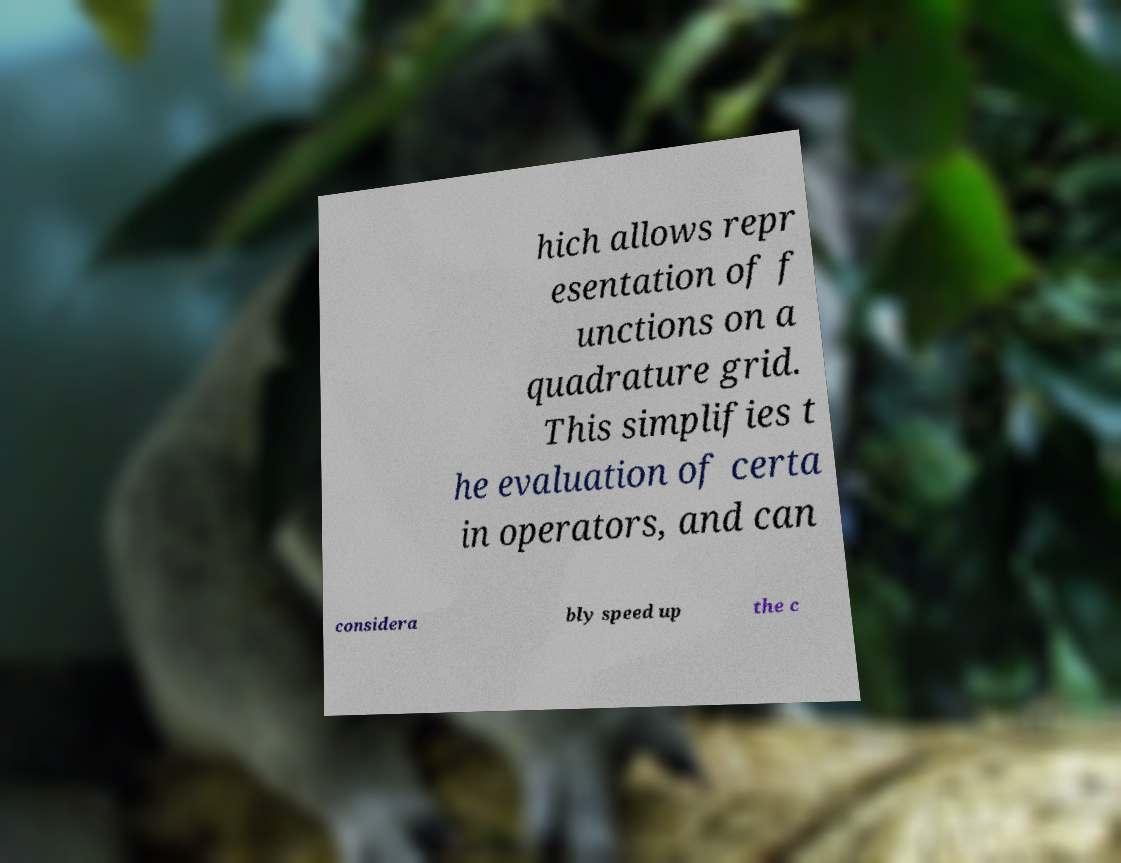There's text embedded in this image that I need extracted. Can you transcribe it verbatim? hich allows repr esentation of f unctions on a quadrature grid. This simplifies t he evaluation of certa in operators, and can considera bly speed up the c 